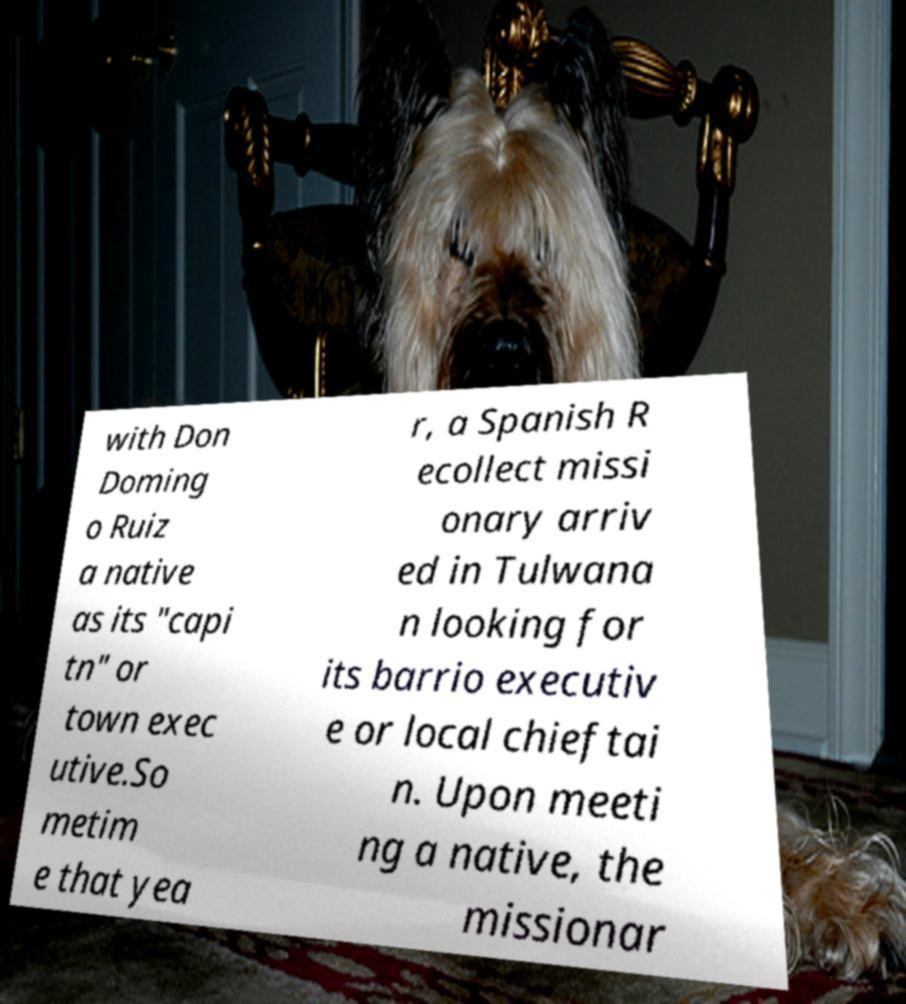Please read and relay the text visible in this image. What does it say? with Don Doming o Ruiz a native as its "capi tn" or town exec utive.So metim e that yea r, a Spanish R ecollect missi onary arriv ed in Tulwana n looking for its barrio executiv e or local chieftai n. Upon meeti ng a native, the missionar 